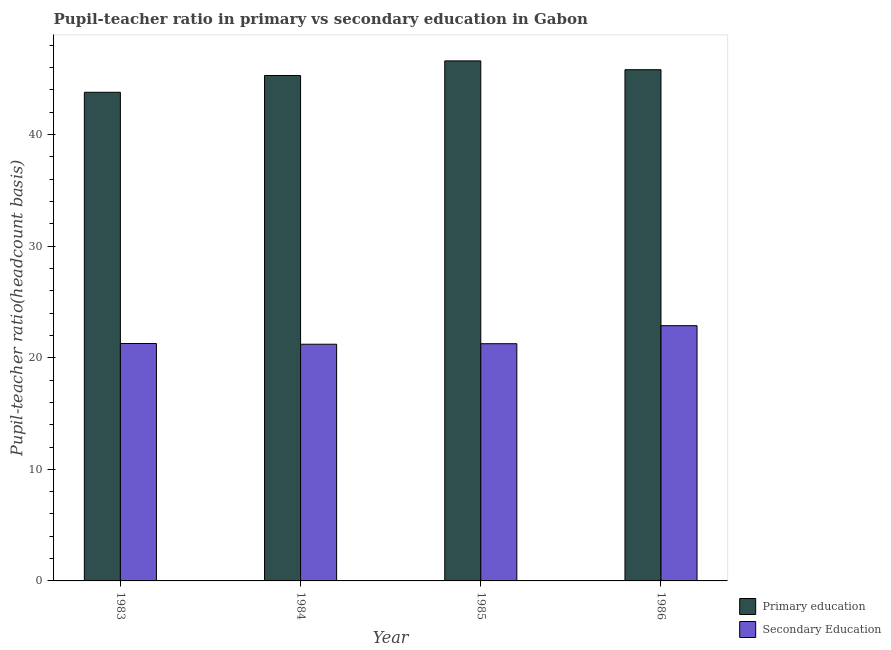How many different coloured bars are there?
Provide a short and direct response. 2. Are the number of bars per tick equal to the number of legend labels?
Provide a succinct answer. Yes. How many bars are there on the 4th tick from the left?
Give a very brief answer. 2. What is the label of the 2nd group of bars from the left?
Ensure brevity in your answer.  1984. In how many cases, is the number of bars for a given year not equal to the number of legend labels?
Give a very brief answer. 0. What is the pupil-teacher ratio in primary education in 1984?
Offer a very short reply. 45.29. Across all years, what is the maximum pupil-teacher ratio in primary education?
Give a very brief answer. 46.6. Across all years, what is the minimum pupil teacher ratio on secondary education?
Offer a terse response. 21.21. In which year was the pupil-teacher ratio in primary education maximum?
Provide a succinct answer. 1985. In which year was the pupil-teacher ratio in primary education minimum?
Your answer should be compact. 1983. What is the total pupil teacher ratio on secondary education in the graph?
Offer a terse response. 86.62. What is the difference between the pupil-teacher ratio in primary education in 1983 and that in 1984?
Your answer should be very brief. -1.51. What is the difference between the pupil teacher ratio on secondary education in 1984 and the pupil-teacher ratio in primary education in 1985?
Ensure brevity in your answer.  -0.05. What is the average pupil-teacher ratio in primary education per year?
Provide a short and direct response. 45.37. In the year 1984, what is the difference between the pupil-teacher ratio in primary education and pupil teacher ratio on secondary education?
Your response must be concise. 0. In how many years, is the pupil-teacher ratio in primary education greater than 30?
Give a very brief answer. 4. What is the ratio of the pupil teacher ratio on secondary education in 1983 to that in 1985?
Make the answer very short. 1. Is the pupil teacher ratio on secondary education in 1983 less than that in 1985?
Make the answer very short. No. Is the difference between the pupil teacher ratio on secondary education in 1985 and 1986 greater than the difference between the pupil-teacher ratio in primary education in 1985 and 1986?
Keep it short and to the point. No. What is the difference between the highest and the second highest pupil teacher ratio on secondary education?
Your answer should be very brief. 1.6. What is the difference between the highest and the lowest pupil-teacher ratio in primary education?
Keep it short and to the point. 2.82. In how many years, is the pupil-teacher ratio in primary education greater than the average pupil-teacher ratio in primary education taken over all years?
Ensure brevity in your answer.  2. What does the 2nd bar from the left in 1985 represents?
Your answer should be very brief. Secondary Education. What does the 1st bar from the right in 1985 represents?
Keep it short and to the point. Secondary Education. Are all the bars in the graph horizontal?
Ensure brevity in your answer.  No. How many years are there in the graph?
Give a very brief answer. 4. Are the values on the major ticks of Y-axis written in scientific E-notation?
Offer a terse response. No. Does the graph contain grids?
Provide a succinct answer. No. Where does the legend appear in the graph?
Your answer should be compact. Bottom right. How are the legend labels stacked?
Offer a very short reply. Vertical. What is the title of the graph?
Your response must be concise. Pupil-teacher ratio in primary vs secondary education in Gabon. What is the label or title of the Y-axis?
Ensure brevity in your answer.  Pupil-teacher ratio(headcount basis). What is the Pupil-teacher ratio(headcount basis) in Primary education in 1983?
Your answer should be very brief. 43.79. What is the Pupil-teacher ratio(headcount basis) in Secondary Education in 1983?
Provide a succinct answer. 21.27. What is the Pupil-teacher ratio(headcount basis) of Primary education in 1984?
Your answer should be very brief. 45.29. What is the Pupil-teacher ratio(headcount basis) in Secondary Education in 1984?
Your answer should be compact. 21.21. What is the Pupil-teacher ratio(headcount basis) of Primary education in 1985?
Your answer should be compact. 46.6. What is the Pupil-teacher ratio(headcount basis) in Secondary Education in 1985?
Make the answer very short. 21.26. What is the Pupil-teacher ratio(headcount basis) in Primary education in 1986?
Offer a terse response. 45.81. What is the Pupil-teacher ratio(headcount basis) in Secondary Education in 1986?
Provide a short and direct response. 22.87. Across all years, what is the maximum Pupil-teacher ratio(headcount basis) in Primary education?
Give a very brief answer. 46.6. Across all years, what is the maximum Pupil-teacher ratio(headcount basis) of Secondary Education?
Provide a short and direct response. 22.87. Across all years, what is the minimum Pupil-teacher ratio(headcount basis) of Primary education?
Provide a succinct answer. 43.79. Across all years, what is the minimum Pupil-teacher ratio(headcount basis) of Secondary Education?
Keep it short and to the point. 21.21. What is the total Pupil-teacher ratio(headcount basis) in Primary education in the graph?
Keep it short and to the point. 181.49. What is the total Pupil-teacher ratio(headcount basis) in Secondary Education in the graph?
Your answer should be very brief. 86.62. What is the difference between the Pupil-teacher ratio(headcount basis) of Primary education in 1983 and that in 1984?
Ensure brevity in your answer.  -1.51. What is the difference between the Pupil-teacher ratio(headcount basis) in Secondary Education in 1983 and that in 1984?
Offer a terse response. 0.06. What is the difference between the Pupil-teacher ratio(headcount basis) in Primary education in 1983 and that in 1985?
Give a very brief answer. -2.82. What is the difference between the Pupil-teacher ratio(headcount basis) in Secondary Education in 1983 and that in 1985?
Make the answer very short. 0.02. What is the difference between the Pupil-teacher ratio(headcount basis) in Primary education in 1983 and that in 1986?
Provide a succinct answer. -2.02. What is the difference between the Pupil-teacher ratio(headcount basis) in Secondary Education in 1983 and that in 1986?
Provide a succinct answer. -1.6. What is the difference between the Pupil-teacher ratio(headcount basis) in Primary education in 1984 and that in 1985?
Make the answer very short. -1.31. What is the difference between the Pupil-teacher ratio(headcount basis) in Secondary Education in 1984 and that in 1985?
Offer a very short reply. -0.05. What is the difference between the Pupil-teacher ratio(headcount basis) of Primary education in 1984 and that in 1986?
Your answer should be compact. -0.52. What is the difference between the Pupil-teacher ratio(headcount basis) in Secondary Education in 1984 and that in 1986?
Offer a very short reply. -1.66. What is the difference between the Pupil-teacher ratio(headcount basis) of Primary education in 1985 and that in 1986?
Offer a very short reply. 0.79. What is the difference between the Pupil-teacher ratio(headcount basis) of Secondary Education in 1985 and that in 1986?
Offer a terse response. -1.62. What is the difference between the Pupil-teacher ratio(headcount basis) of Primary education in 1983 and the Pupil-teacher ratio(headcount basis) of Secondary Education in 1984?
Keep it short and to the point. 22.58. What is the difference between the Pupil-teacher ratio(headcount basis) in Primary education in 1983 and the Pupil-teacher ratio(headcount basis) in Secondary Education in 1985?
Make the answer very short. 22.53. What is the difference between the Pupil-teacher ratio(headcount basis) of Primary education in 1983 and the Pupil-teacher ratio(headcount basis) of Secondary Education in 1986?
Provide a short and direct response. 20.91. What is the difference between the Pupil-teacher ratio(headcount basis) in Primary education in 1984 and the Pupil-teacher ratio(headcount basis) in Secondary Education in 1985?
Give a very brief answer. 24.04. What is the difference between the Pupil-teacher ratio(headcount basis) of Primary education in 1984 and the Pupil-teacher ratio(headcount basis) of Secondary Education in 1986?
Your answer should be compact. 22.42. What is the difference between the Pupil-teacher ratio(headcount basis) in Primary education in 1985 and the Pupil-teacher ratio(headcount basis) in Secondary Education in 1986?
Your answer should be very brief. 23.73. What is the average Pupil-teacher ratio(headcount basis) of Primary education per year?
Your response must be concise. 45.37. What is the average Pupil-teacher ratio(headcount basis) of Secondary Education per year?
Keep it short and to the point. 21.65. In the year 1983, what is the difference between the Pupil-teacher ratio(headcount basis) of Primary education and Pupil-teacher ratio(headcount basis) of Secondary Education?
Your response must be concise. 22.51. In the year 1984, what is the difference between the Pupil-teacher ratio(headcount basis) of Primary education and Pupil-teacher ratio(headcount basis) of Secondary Education?
Your response must be concise. 24.08. In the year 1985, what is the difference between the Pupil-teacher ratio(headcount basis) in Primary education and Pupil-teacher ratio(headcount basis) in Secondary Education?
Provide a succinct answer. 25.35. In the year 1986, what is the difference between the Pupil-teacher ratio(headcount basis) in Primary education and Pupil-teacher ratio(headcount basis) in Secondary Education?
Your answer should be compact. 22.94. What is the ratio of the Pupil-teacher ratio(headcount basis) in Primary education in 1983 to that in 1984?
Your answer should be compact. 0.97. What is the ratio of the Pupil-teacher ratio(headcount basis) in Secondary Education in 1983 to that in 1984?
Offer a very short reply. 1. What is the ratio of the Pupil-teacher ratio(headcount basis) of Primary education in 1983 to that in 1985?
Provide a short and direct response. 0.94. What is the ratio of the Pupil-teacher ratio(headcount basis) of Secondary Education in 1983 to that in 1985?
Ensure brevity in your answer.  1. What is the ratio of the Pupil-teacher ratio(headcount basis) in Primary education in 1983 to that in 1986?
Provide a short and direct response. 0.96. What is the ratio of the Pupil-teacher ratio(headcount basis) in Secondary Education in 1983 to that in 1986?
Provide a succinct answer. 0.93. What is the ratio of the Pupil-teacher ratio(headcount basis) in Primary education in 1984 to that in 1985?
Provide a short and direct response. 0.97. What is the ratio of the Pupil-teacher ratio(headcount basis) of Secondary Education in 1984 to that in 1985?
Ensure brevity in your answer.  1. What is the ratio of the Pupil-teacher ratio(headcount basis) of Primary education in 1984 to that in 1986?
Provide a succinct answer. 0.99. What is the ratio of the Pupil-teacher ratio(headcount basis) in Secondary Education in 1984 to that in 1986?
Provide a short and direct response. 0.93. What is the ratio of the Pupil-teacher ratio(headcount basis) of Primary education in 1985 to that in 1986?
Ensure brevity in your answer.  1.02. What is the ratio of the Pupil-teacher ratio(headcount basis) in Secondary Education in 1985 to that in 1986?
Provide a short and direct response. 0.93. What is the difference between the highest and the second highest Pupil-teacher ratio(headcount basis) of Primary education?
Offer a terse response. 0.79. What is the difference between the highest and the second highest Pupil-teacher ratio(headcount basis) of Secondary Education?
Your answer should be very brief. 1.6. What is the difference between the highest and the lowest Pupil-teacher ratio(headcount basis) in Primary education?
Your response must be concise. 2.82. What is the difference between the highest and the lowest Pupil-teacher ratio(headcount basis) in Secondary Education?
Offer a very short reply. 1.66. 